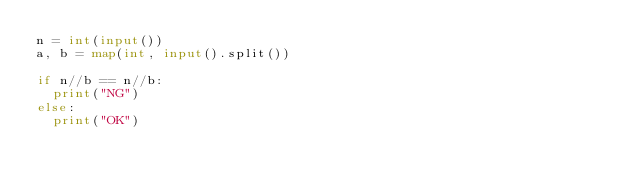Convert code to text. <code><loc_0><loc_0><loc_500><loc_500><_Python_>n = int(input())
a, b = map(int, input().split())

if n//b == n//b:
  print("NG")
else:
  print("OK")</code> 